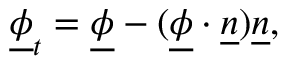<formula> <loc_0><loc_0><loc_500><loc_500>\underline { \phi } _ { t } = \underline { \phi } - ( \underline { \phi } \cdot \underline { n } ) \underline { n } ,</formula> 